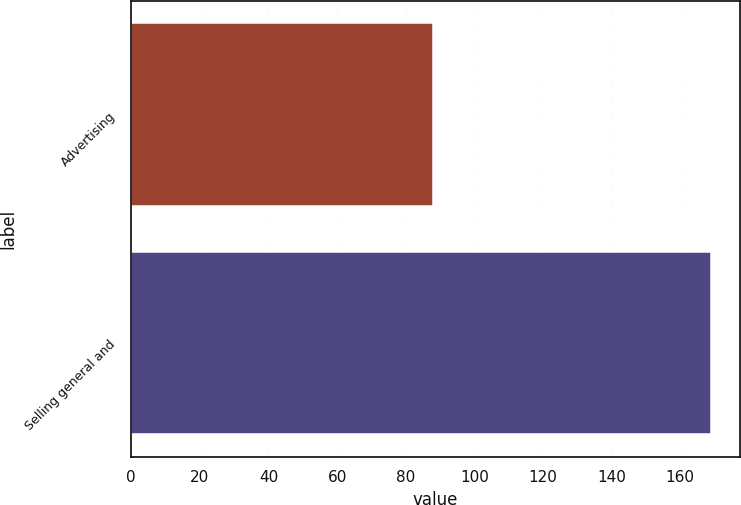<chart> <loc_0><loc_0><loc_500><loc_500><bar_chart><fcel>Advertising<fcel>Selling general and<nl><fcel>88<fcel>169<nl></chart> 